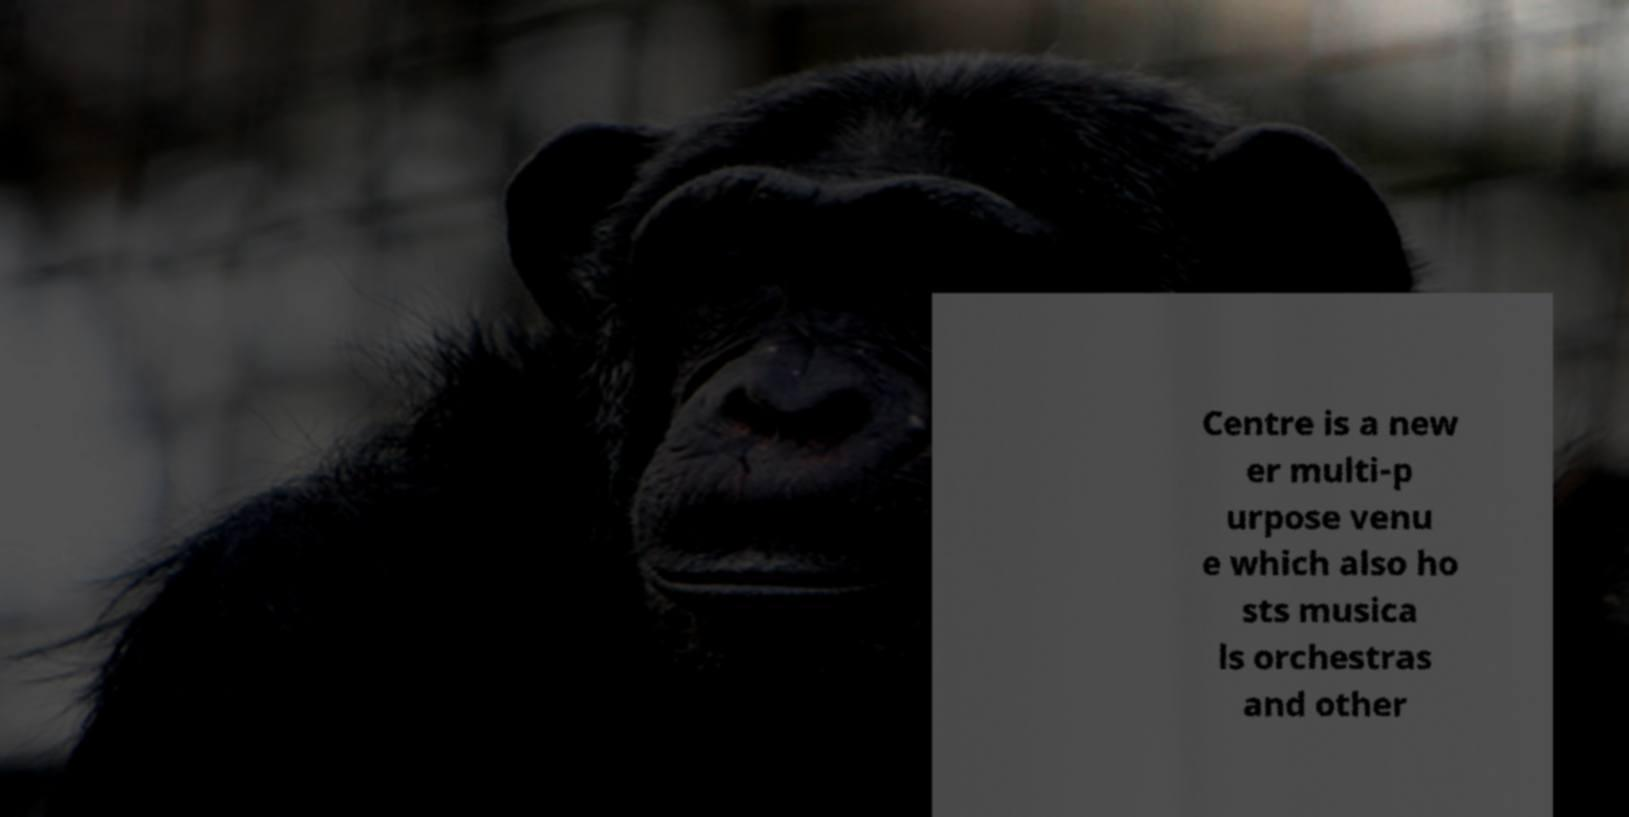Can you read and provide the text displayed in the image?This photo seems to have some interesting text. Can you extract and type it out for me? Centre is a new er multi-p urpose venu e which also ho sts musica ls orchestras and other 